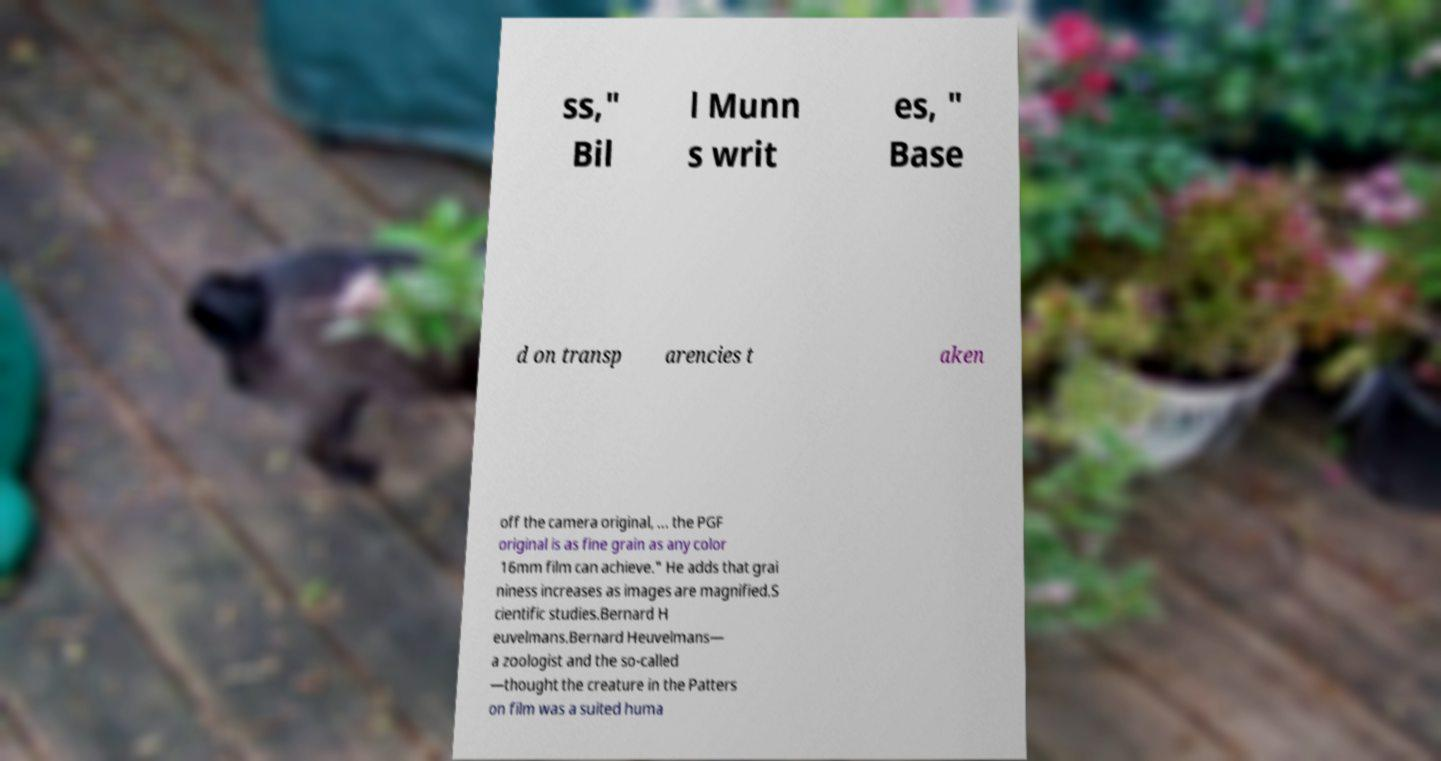There's text embedded in this image that I need extracted. Can you transcribe it verbatim? ss," Bil l Munn s writ es, " Base d on transp arencies t aken off the camera original, ... the PGF original is as fine grain as any color 16mm film can achieve." He adds that grai niness increases as images are magnified.S cientific studies.Bernard H euvelmans.Bernard Heuvelmans— a zoologist and the so-called —thought the creature in the Patters on film was a suited huma 